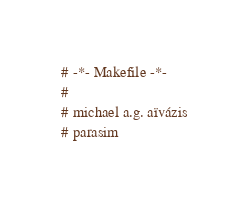Convert code to text. <code><loc_0><loc_0><loc_500><loc_500><_ObjectiveC_># -*- Makefile -*-
#
# michael a.g. aïvázis
# parasim</code> 